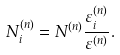Convert formula to latex. <formula><loc_0><loc_0><loc_500><loc_500>N _ { i } ^ { ( n ) } = N ^ { ( n ) } \frac { \varepsilon _ { i } ^ { ( n ) } } { \varepsilon ^ { ( n ) } } .</formula> 